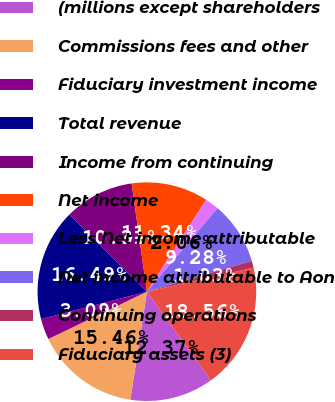Convert chart. <chart><loc_0><loc_0><loc_500><loc_500><pie_chart><fcel>(millions except shareholders<fcel>Commissions fees and other<fcel>Fiduciary investment income<fcel>Total revenue<fcel>Income from continuing<fcel>Net income<fcel>Less Net income attributable<fcel>Net income attributable to Aon<fcel>Continuing operations<fcel>Fiduciary assets (3)<nl><fcel>12.37%<fcel>15.46%<fcel>3.09%<fcel>16.49%<fcel>10.31%<fcel>11.34%<fcel>2.06%<fcel>9.28%<fcel>1.03%<fcel>18.56%<nl></chart> 